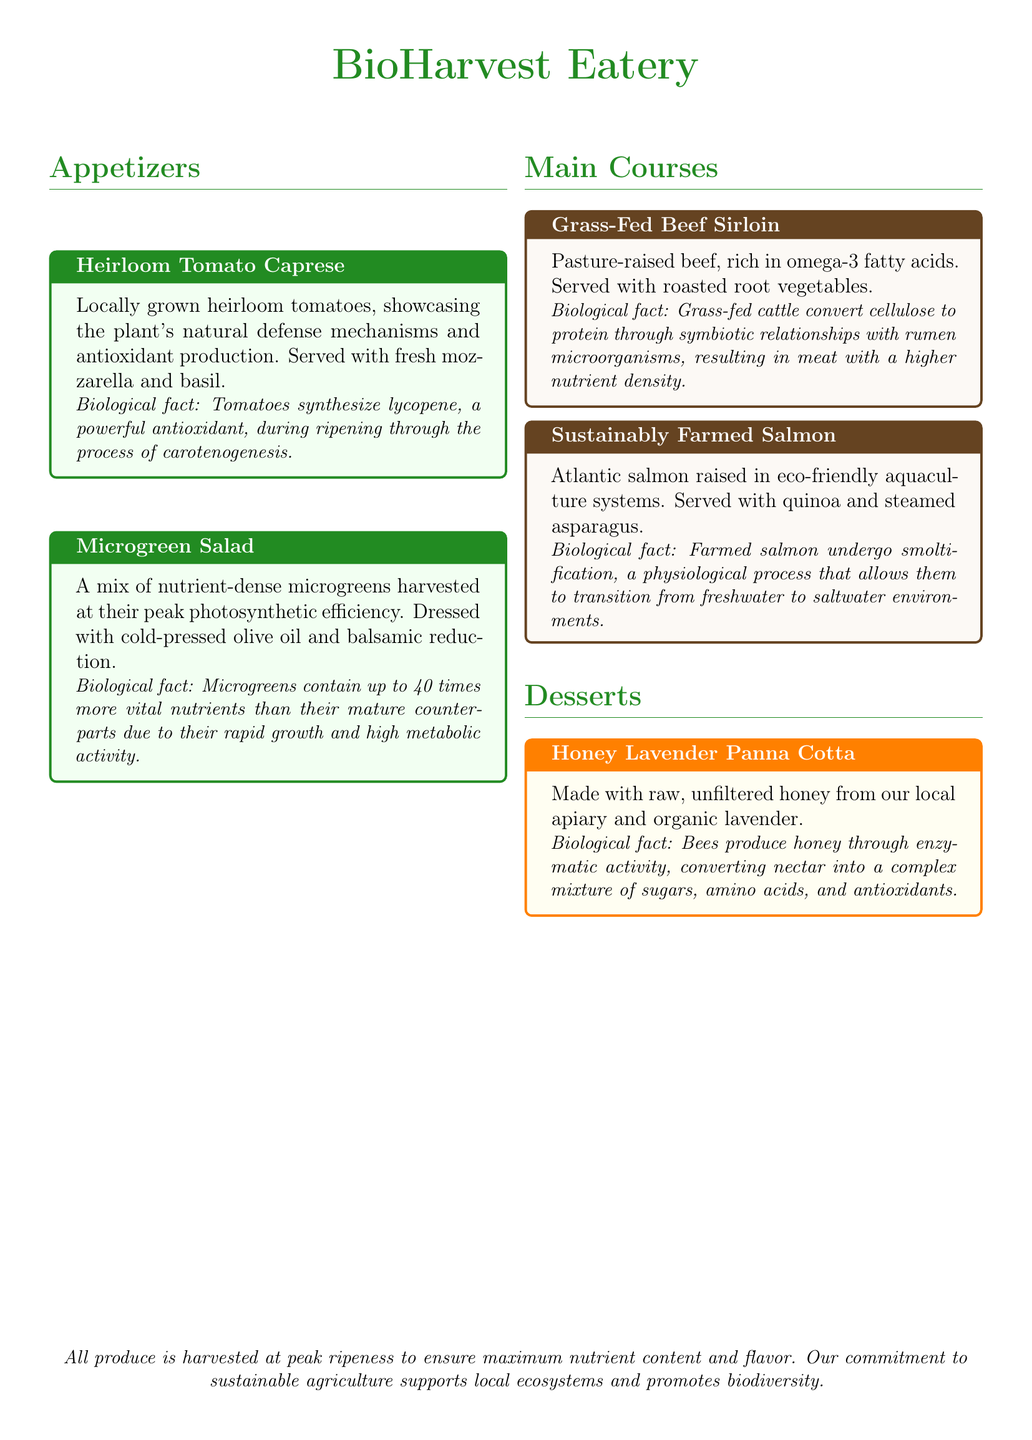What is the first appetizer listed? The first appetizer in the document is "Heirloom Tomato Caprese".
Answer: Heirloom Tomato Caprese How are the tomatoes in the appetizer grown? The tomatoes are locally grown, and the menu notes their natural defense mechanisms and antioxidant production.
Answer: Locally grown What type of fat is emphasized in the Grass-Fed Beef Sirloin? The menu highlights omega-3 fatty acids in the grass-fed beef.
Answer: Omega-3 fatty acids What process do farmed salmon undergo? The document mentions that farmed salmon undergo smoltification to transition environments.
Answer: Smoltification What is a key feature of microgreens according to the menu? The menu states that microgreens are harvested at their peak photosynthetic efficiency.
Answer: Peak photosynthetic efficiency What unique ingredient is used in the Honey Lavender Panna Cotta? The dessert features raw, unfiltered honey from a local apiary.
Answer: Raw, unfiltered honey How do bees produce honey? Bees produce honey through enzymatic activity in converting nectar.
Answer: Enzymatic activity What commitment does the eatery express regarding agriculture? The eatery expresses a commitment to sustainable agriculture.
Answer: Sustainable agriculture 